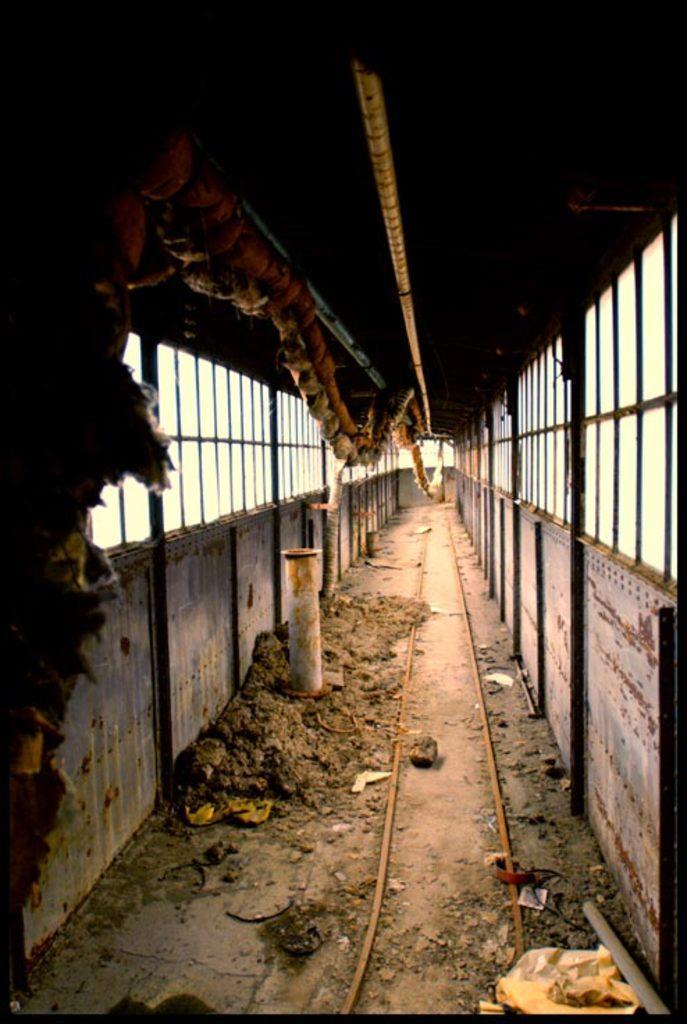Could you give a brief overview of what you see in this image? In the center of the image we can see a rod. At the top there are ropes. In the background we can see windows. 